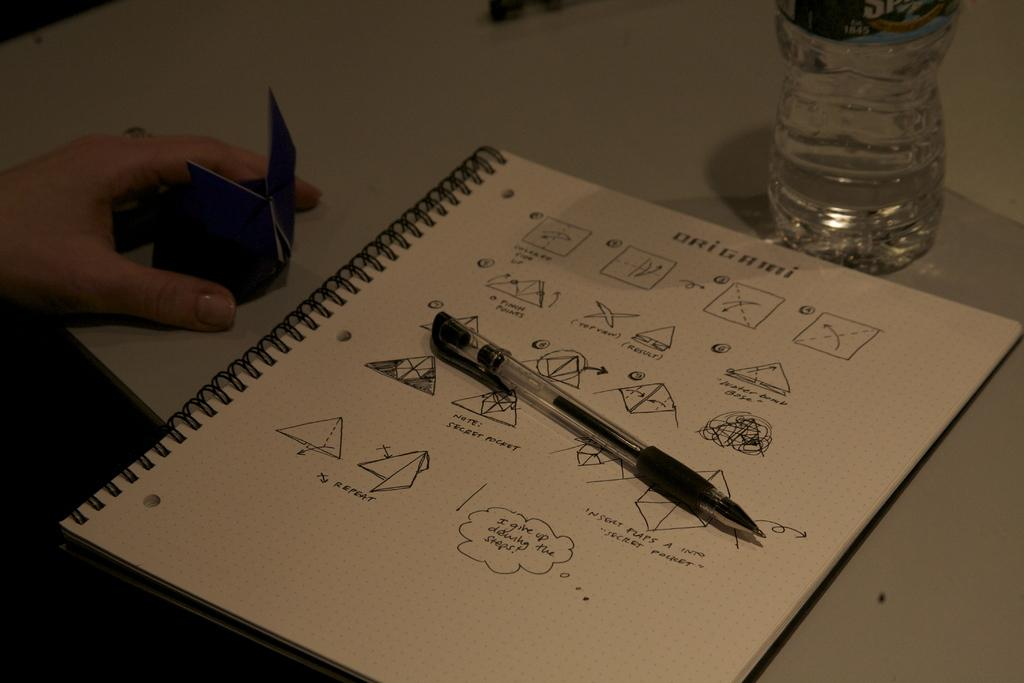What is one of the objects in the image that can be used for writing? There is a pen in the image that can be used for writing. What is the hand in the image doing? The hand in the image is likely holding or interacting with one of the objects on the table. What is the purpose of the paper in the image? The paper in the image could be used for writing, drawing, or other creative activities. What is the bottle in the image used for? The bottle in the image could be used for holding water, ink, or other liquids. Where are all these objects located in the image? All these objects are on a table in the image. What type of duck can be seen swimming in the sink in the image? There is no duck or sink present in the image. 